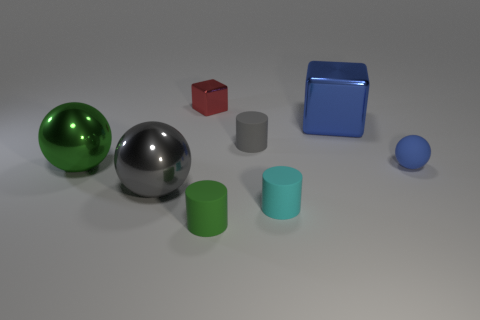Are there fewer blue blocks than big brown metallic things?
Offer a terse response. No. How many metallic objects are either large gray objects or large blue things?
Your answer should be compact. 2. There is a gray thing that is to the left of the red cube; are there any cyan matte objects on the left side of it?
Provide a short and direct response. No. Is the ball that is behind the big green object made of the same material as the large gray ball?
Provide a short and direct response. No. What number of other things are the same color as the small rubber sphere?
Give a very brief answer. 1. Is the color of the large block the same as the tiny ball?
Your answer should be compact. Yes. How big is the blue thing left of the ball behind the green shiny object?
Provide a short and direct response. Large. Do the green thing to the left of the green matte cylinder and the large thing behind the small gray cylinder have the same material?
Provide a succinct answer. Yes. There is a ball behind the big green object; is its color the same as the big metallic cube?
Offer a terse response. Yes. How many gray metal balls are on the right side of the blue sphere?
Offer a very short reply. 0. 